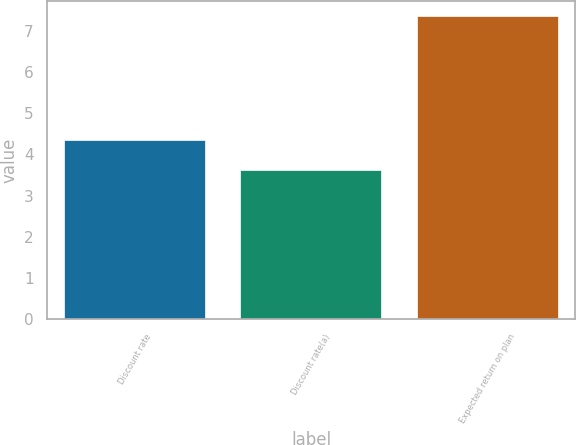<chart> <loc_0><loc_0><loc_500><loc_500><bar_chart><fcel>Discount rate<fcel>Discount rate(a)<fcel>Expected return on plan<nl><fcel>4.34<fcel>3.62<fcel>7.35<nl></chart> 